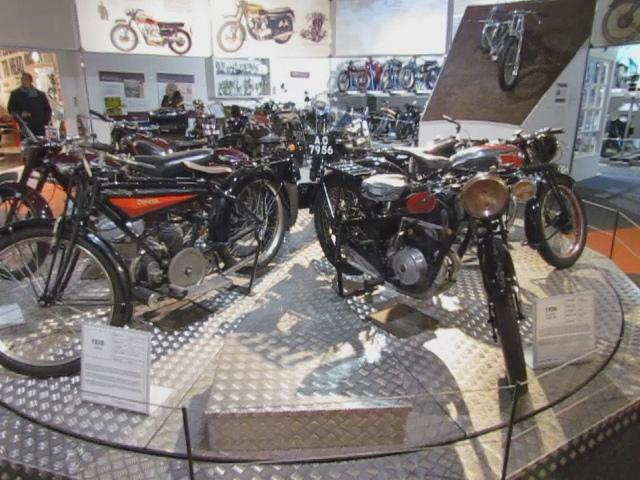What type room is this?

Choices:
A) parking garage
B) bathroom
C) living
D) showroom showroom 